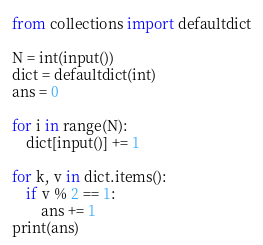<code> <loc_0><loc_0><loc_500><loc_500><_Python_>from collections import defaultdict

N = int(input())
dict = defaultdict(int)
ans = 0

for i in range(N):
    dict[input()] += 1

for k, v in dict.items():
    if v % 2 == 1:
        ans += 1
print(ans)
</code> 